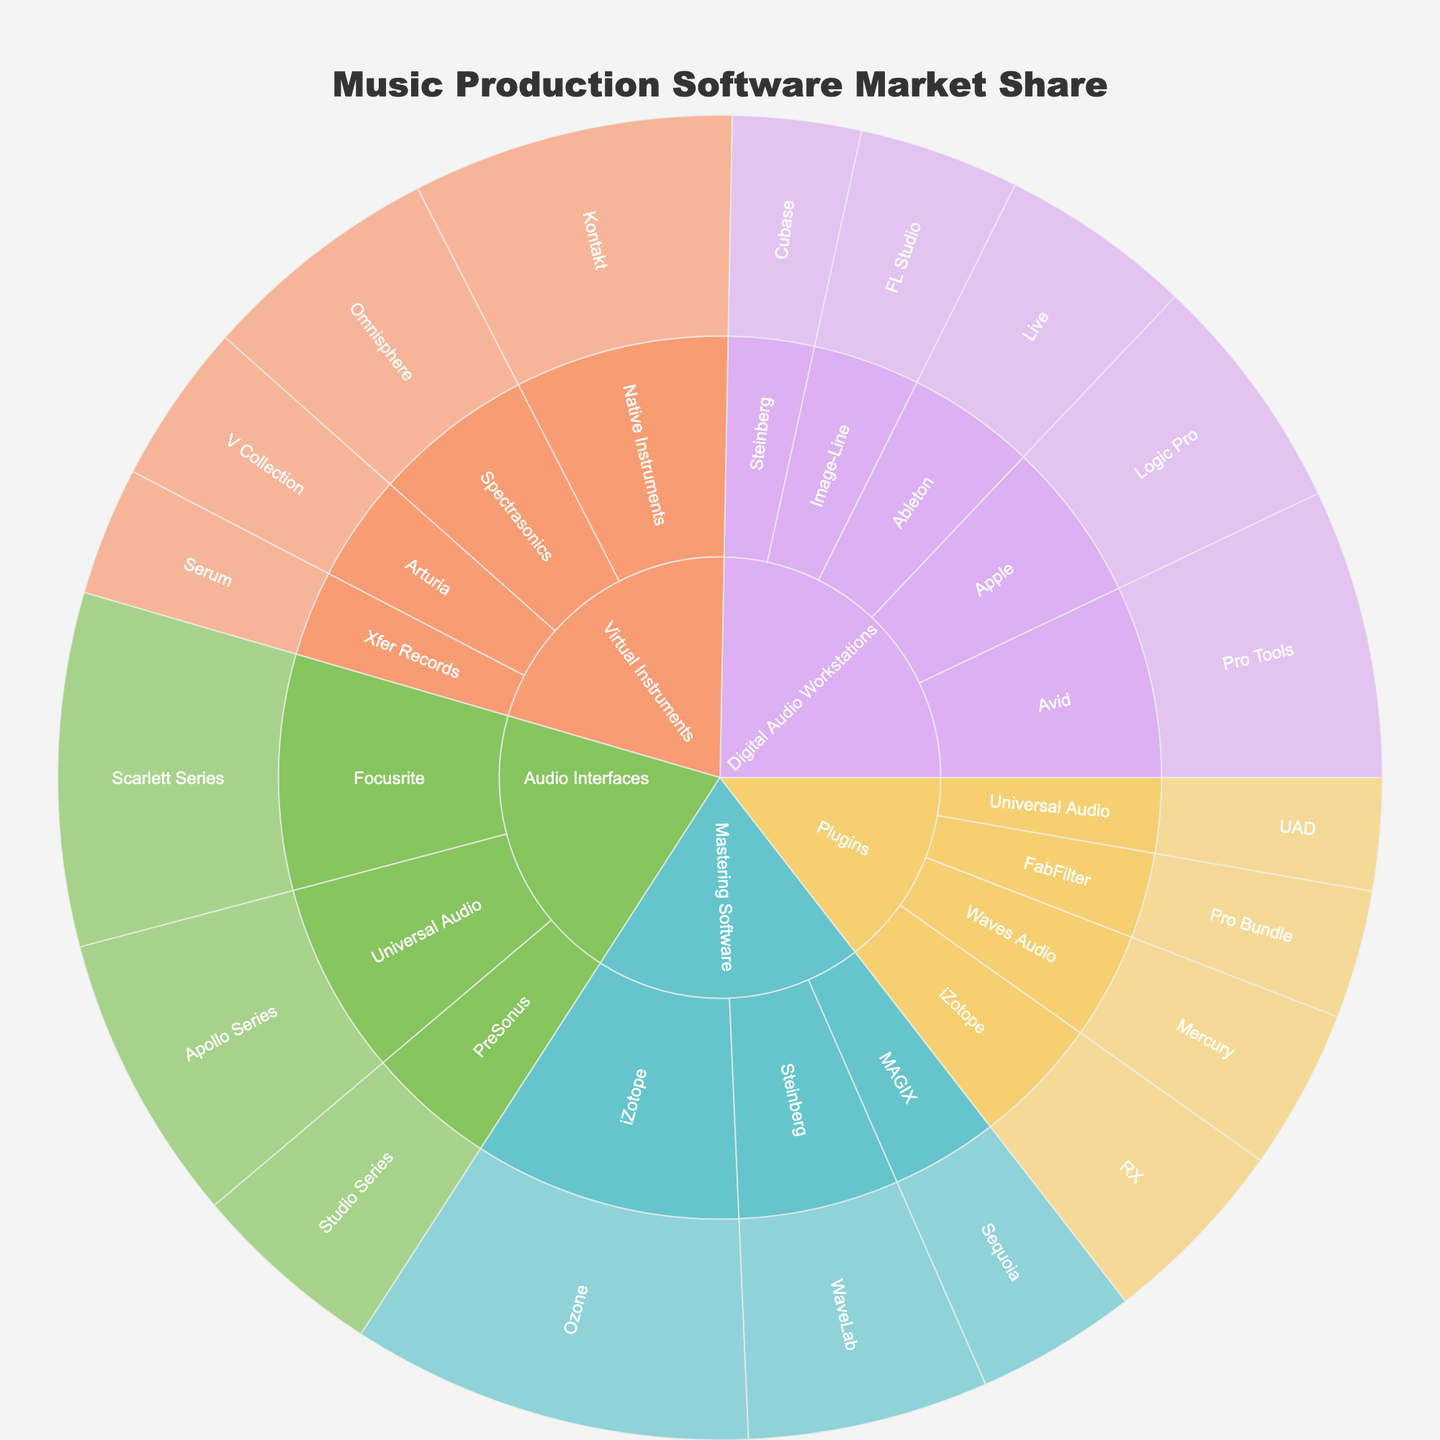What is the total market share of the Digital Audio Workstations category? To find the total market share of the Digital Audio Workstations category, sum the market shares of all its subcategories: Pro Tools (18), Logic Pro (15), Live (12), FL Studio (10), and Cubase (8). The sum is 18 + 15 + 12 + 10 + 8 = 63.
Answer: 63% Which product within the Virtual Instruments category has the highest market share? Look at the sunburst plot section for the Virtual Instruments category and identify the product with the largest segment. Kontakt holds the highest share at 20%.
Answer: Kontakt Compare the market share between the top products in the Mastering Software and Plugins categories. Which product has the higher market share and by how much? The top product in Mastering Software is Ozone (25%) and in Plugins is RX (12%). To find the difference, subtract 12 from 25. 25 - 12 = 13. Ozone has the higher market share by 13%.
Answer: Ozone by 13% How does the market share of Universal Audio's Apollo Series compare to its UAD plugins? Look for Universal Audio's products and compare their shares: Apollo Series has 18% and UAD plugins have 7%. 18 is greater than 7 by 11.
Answer: Apollo Series by 11% Which category has the single highest market share for any product? Examine the sunburst plot to find the largest single segment across all categories. Ozone (Mastering Software) has the highest share at 25%.
Answer: Mastering Software What is the combined market share of all products under the Plugins category? Sum the market shares of all products under Plugins: RX (12), Mercury (10), Pro Bundle (8), UAD (7). The combined share is 12 + 10 + 8 + 7 = 37.
Answer: 37% What proportion of the Audio Interfaces category does the Scarlett Series represent? Find the market share of Scarlett Series (22%) and the total for Audio Interfaces category: Scarlett Series (22) + Apollo Series (18) + Studio Series (12) = 52. Then calculate 22 / 52 ≈ 0.423 or 42.3%.
Answer: 42.3% Which Digital Audio Workstation product has the smallest market share and what is it? Identify the smallest segment in the Digital Audio Workstations category. Cubase has the smallest share at 8%.
Answer: Cubase If an additional product were added to the Digital Audio Workstations category with a market share of 10%, what would be the new total for the category? The original total is 63%. Adding the new product's share: 63 + 10 = 73. The new total would be 73%.
Answer: 73% How many products have a market share greater than 15% and in which categories do they belong? Identify products with more than 15% market share. They are Pro Tools (18% - Digital Audio Workstations), Kontakt (20% - Virtual Instruments), Ozone (25% - Mastering Software), Scarlett Series (22% - Audio Interfaces), and Apollo Series (18% - Audio Interfaces). There are 5 products in total, belonging to 4 categories: Digital Audio Workstations, Virtual Instruments, Mastering Software, and Audio Interfaces.
Answer: 5 products in 4 categories 